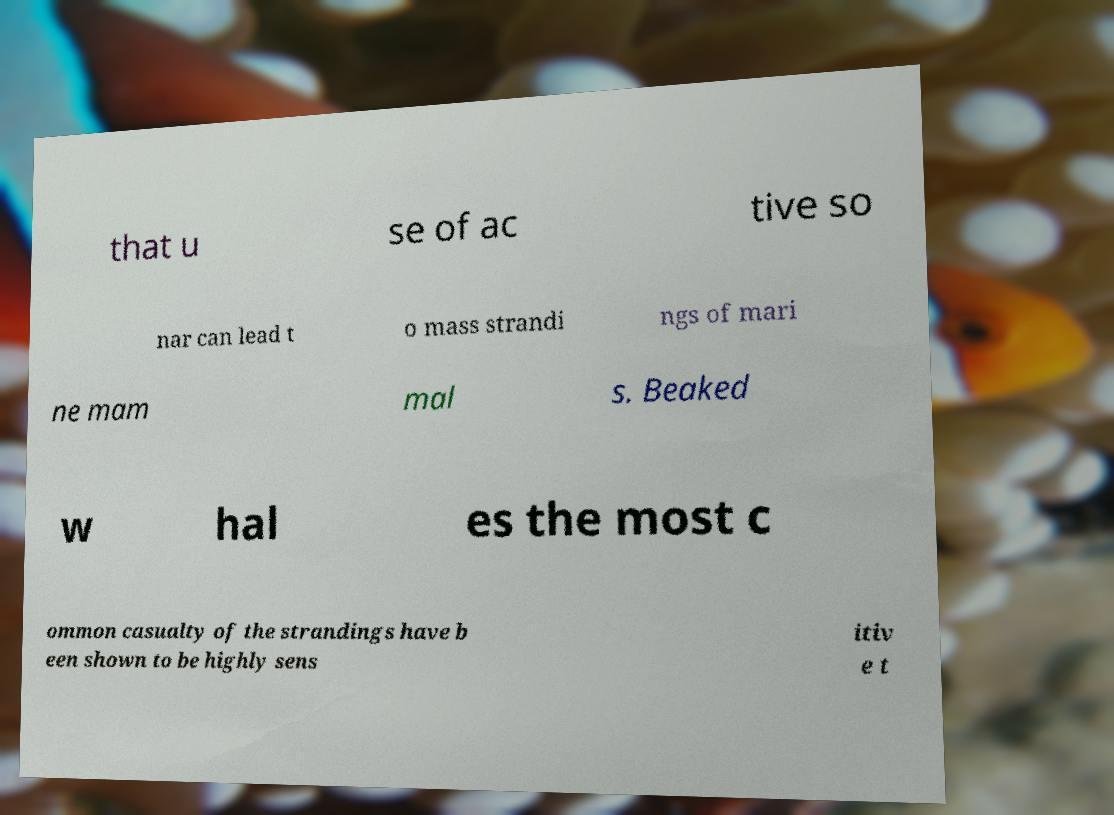What messages or text are displayed in this image? I need them in a readable, typed format. that u se of ac tive so nar can lead t o mass strandi ngs of mari ne mam mal s. Beaked w hal es the most c ommon casualty of the strandings have b een shown to be highly sens itiv e t 